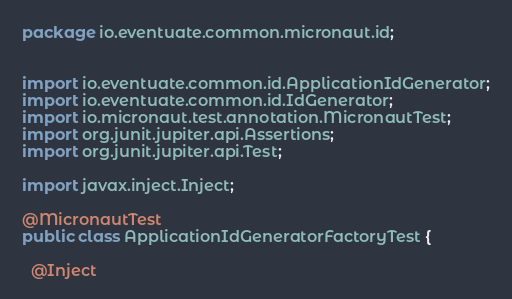Convert code to text. <code><loc_0><loc_0><loc_500><loc_500><_Java_>package io.eventuate.common.micronaut.id;


import io.eventuate.common.id.ApplicationIdGenerator;
import io.eventuate.common.id.IdGenerator;
import io.micronaut.test.annotation.MicronautTest;
import org.junit.jupiter.api.Assertions;
import org.junit.jupiter.api.Test;

import javax.inject.Inject;

@MicronautTest
public class ApplicationIdGeneratorFactoryTest {

  @Inject</code> 